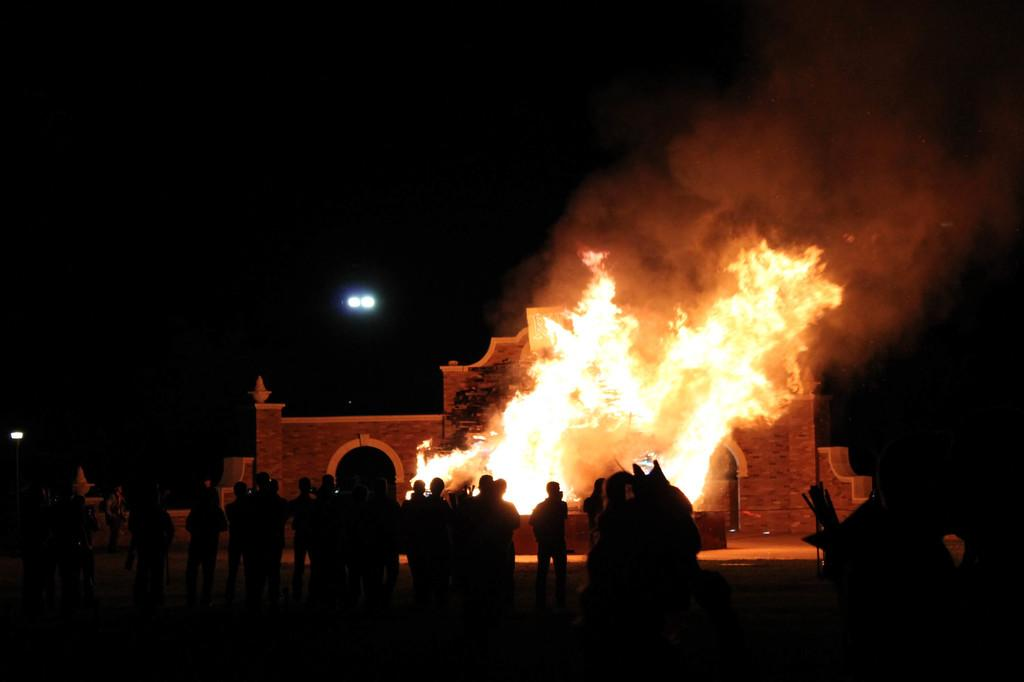What can be seen in the foreground of the image? There are people standing in the foreground of the image. What is happening in the middle of the image? There is a fire burning in the middle of the image. How does the snow affect the doll in the image? There is no snow or doll present in the image. What sense is being stimulated by the fire in the image? The question is not relevant to the image, as it does not mention any sensory experiences related to the fire. 